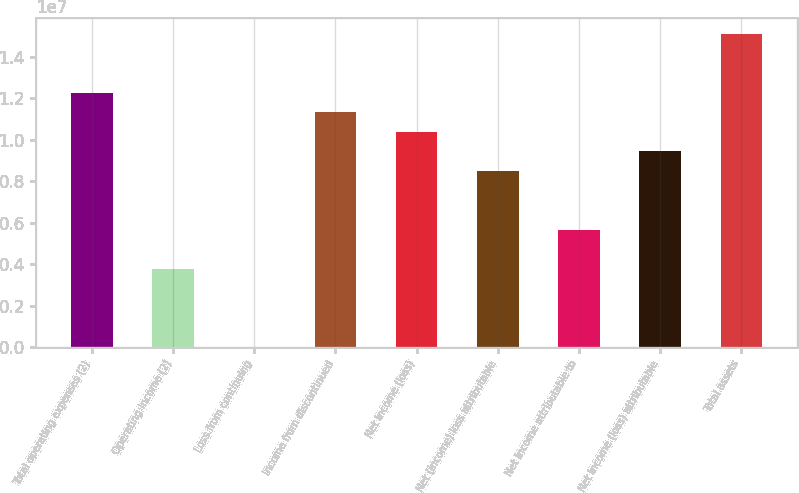<chart> <loc_0><loc_0><loc_500><loc_500><bar_chart><fcel>Total operating expenses (2)<fcel>Operating income (2)<fcel>Loss from continuing<fcel>Income from discontinued<fcel>Net income (loss)<fcel>Net (income) loss attributable<fcel>Net income attributable to<fcel>Net income (loss) attributable<fcel>Total assets<nl><fcel>1.22744e+07<fcel>3.77675e+06<fcel>2.11<fcel>1.13302e+07<fcel>1.03861e+07<fcel>8.49768e+06<fcel>5.66512e+06<fcel>9.44187e+06<fcel>1.5107e+07<nl></chart> 